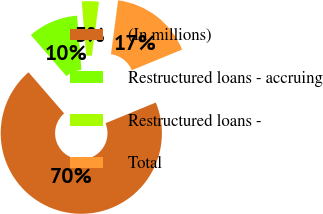<chart> <loc_0><loc_0><loc_500><loc_500><pie_chart><fcel>(In millions)<fcel>Restructured loans - accruing<fcel>Restructured loans -<fcel>Total<nl><fcel>69.86%<fcel>10.05%<fcel>3.4%<fcel>16.69%<nl></chart> 